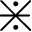Convert formula to latex. <formula><loc_0><loc_0><loc_500><loc_500>\divideontimes</formula> 